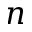Convert formula to latex. <formula><loc_0><loc_0><loc_500><loc_500>n</formula> 